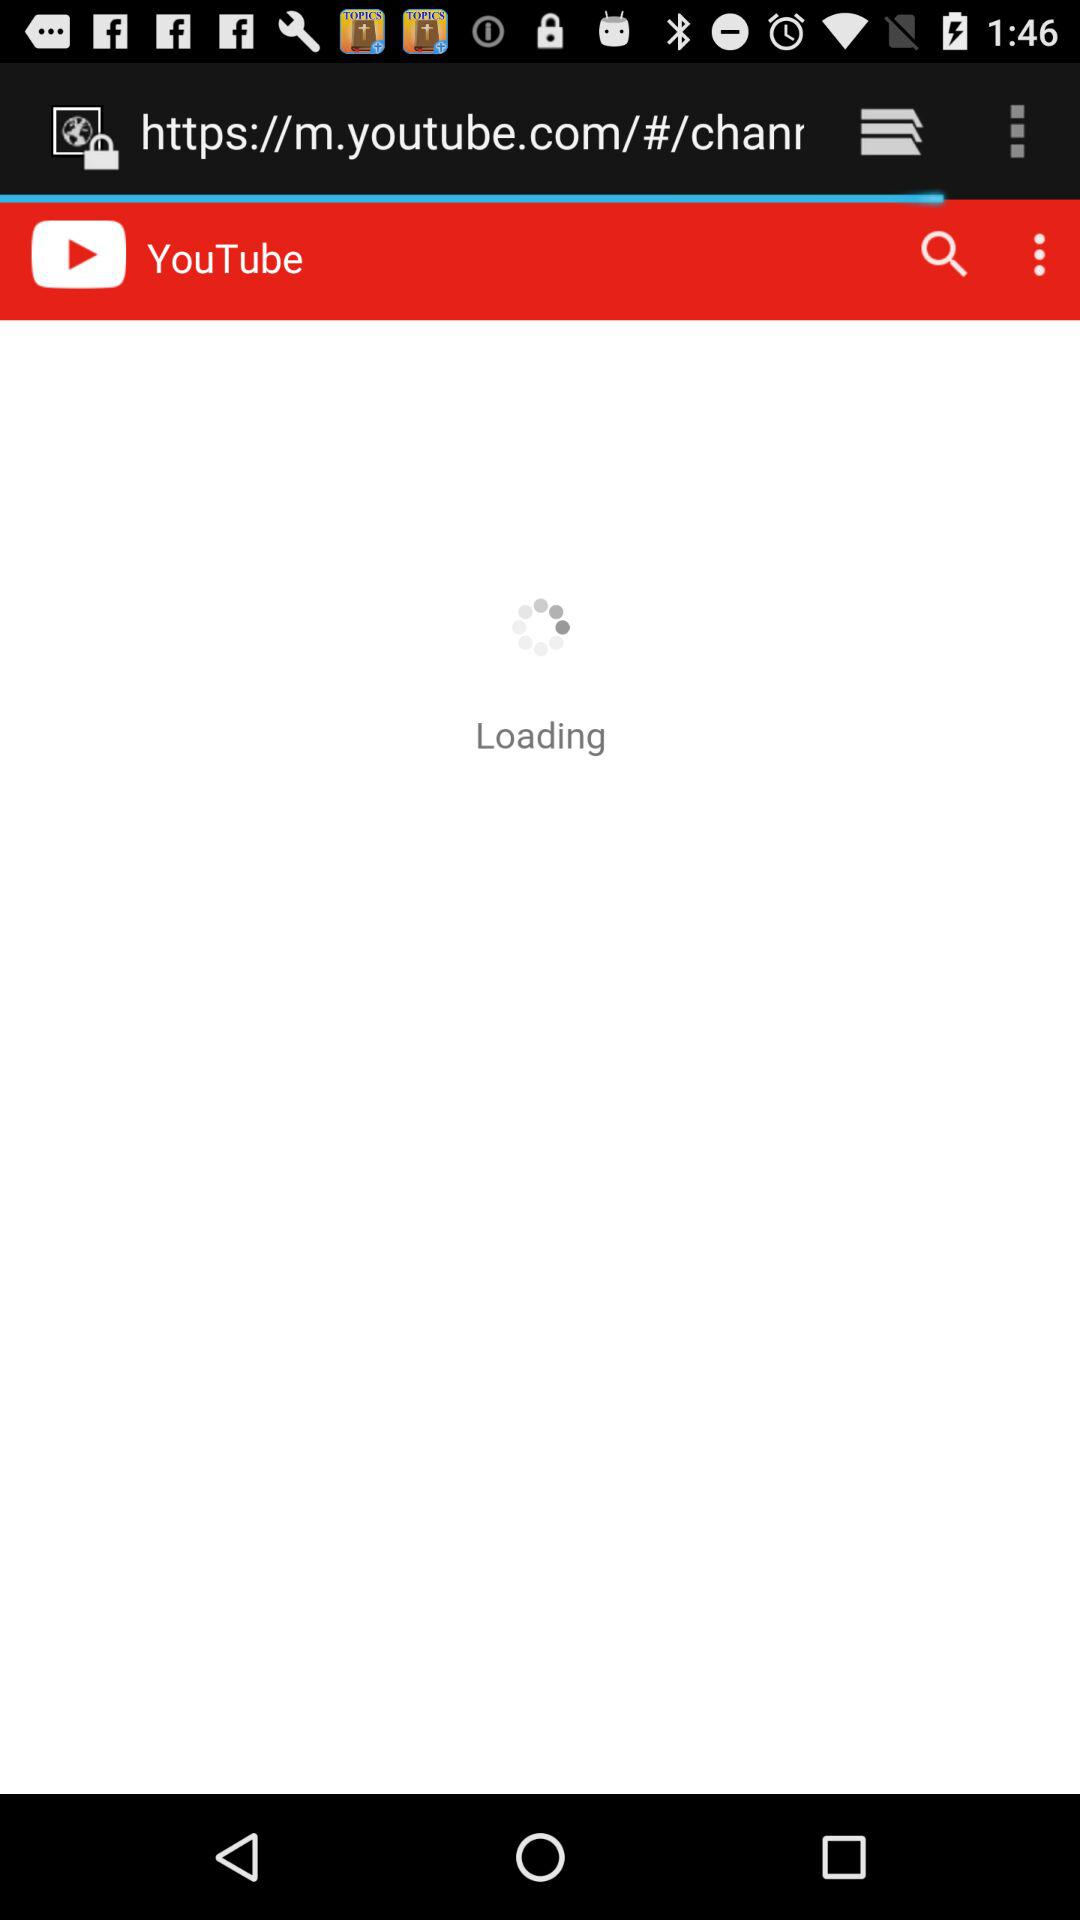What is the app name? The app name is "YouTube". 